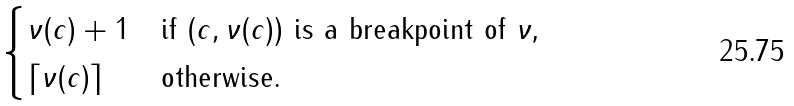Convert formula to latex. <formula><loc_0><loc_0><loc_500><loc_500>\begin{cases} \nu ( c ) + 1 & \text {if $(c,\nu(c))$ is a breakpoint of $\nu$,} \\ \lceil \nu ( c ) \rceil & \text {otherwise.} \end{cases}</formula> 